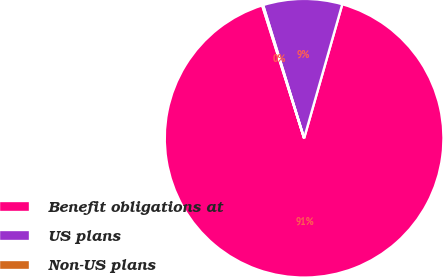<chart> <loc_0><loc_0><loc_500><loc_500><pie_chart><fcel>Benefit obligations at<fcel>US plans<fcel>Non-US plans<nl><fcel>90.71%<fcel>9.17%<fcel>0.11%<nl></chart> 